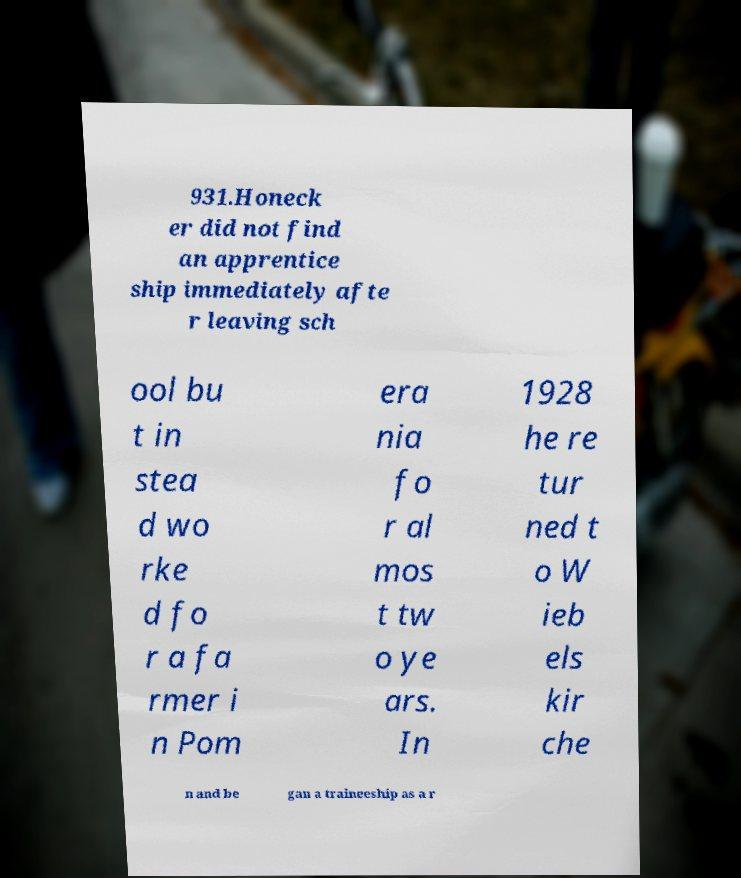Can you accurately transcribe the text from the provided image for me? 931.Honeck er did not find an apprentice ship immediately afte r leaving sch ool bu t in stea d wo rke d fo r a fa rmer i n Pom era nia fo r al mos t tw o ye ars. In 1928 he re tur ned t o W ieb els kir che n and be gan a traineeship as a r 